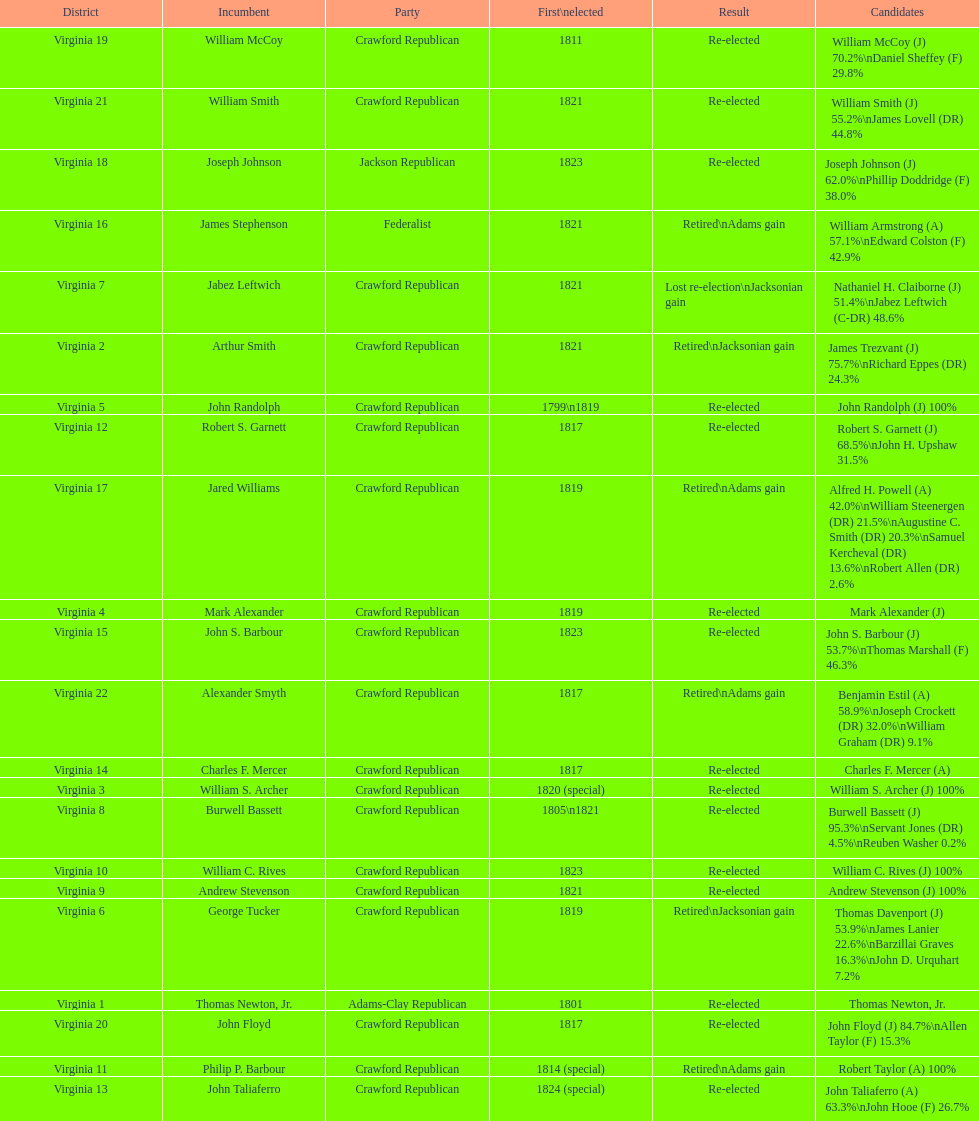What is the concluding party on this chart? Crawford Republican. 